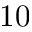Convert formula to latex. <formula><loc_0><loc_0><loc_500><loc_500>1 0</formula> 